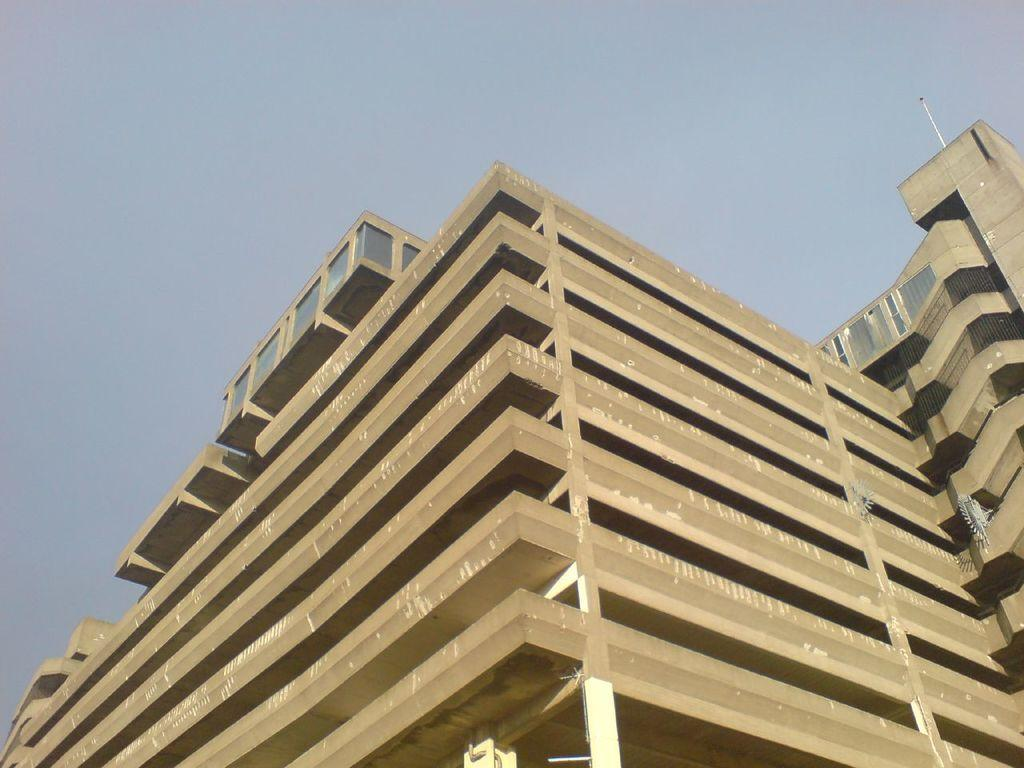What type of structures can be seen in the image? There are buildings in the image. Can you describe any specific features of the buildings? There is a metal rod on one of the buildings. What type of sheet is covering the buildings in the image? There is no sheet covering the buildings in the image. 